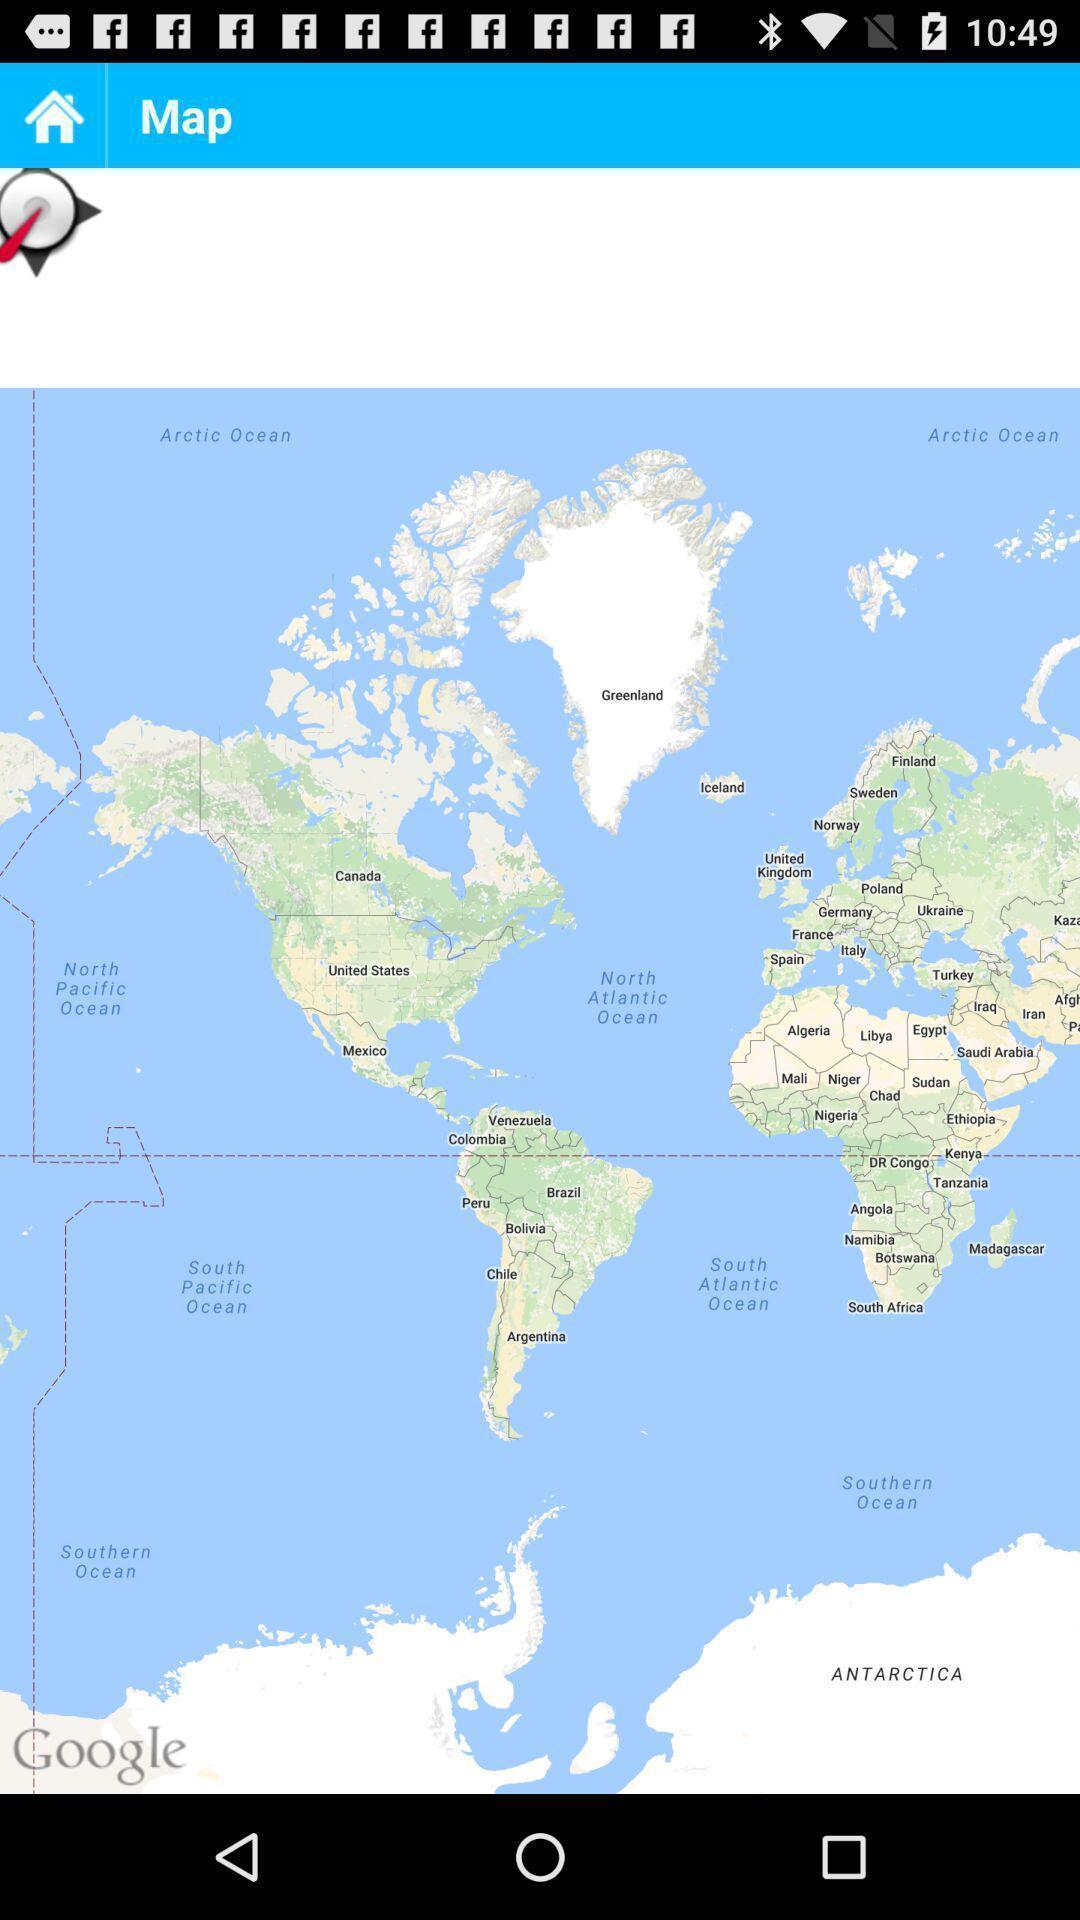Provide a description of this screenshot. Screen displaying the map of a bus guide app. 